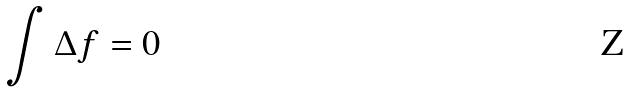Convert formula to latex. <formula><loc_0><loc_0><loc_500><loc_500>\int \Delta f = 0</formula> 